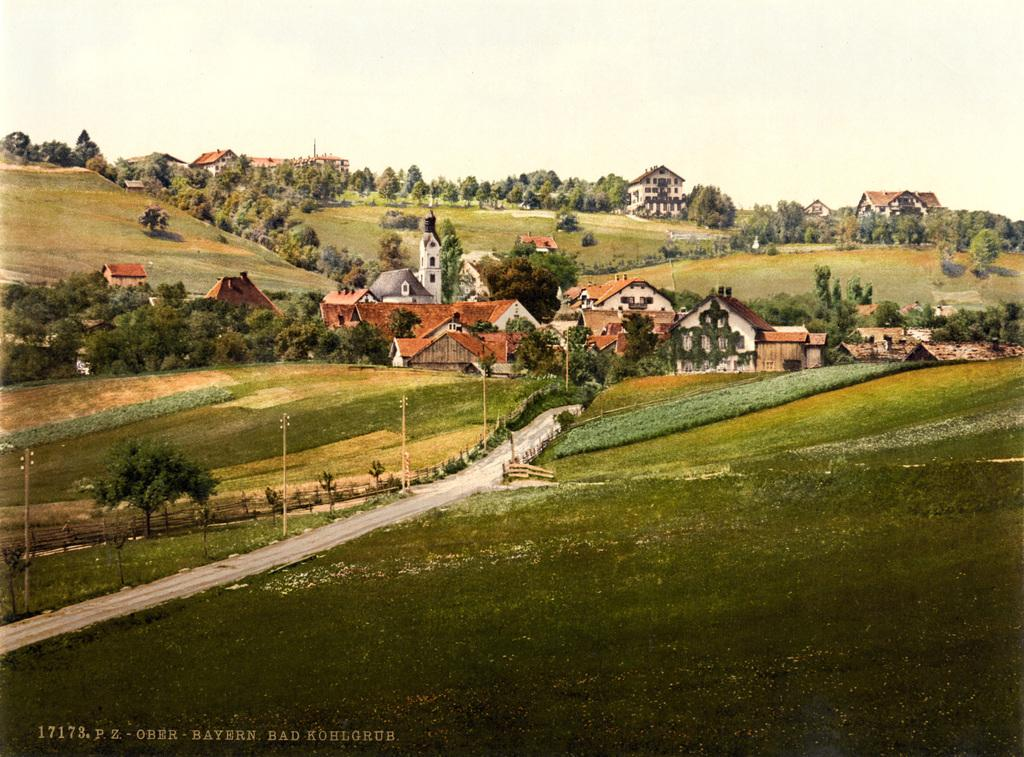What type of vegetation can be seen in the image? There are trees in the image. What is the color of the trees? The trees are green. What structures are present in the image? There are electric poles in the image. What can be seen in the background of the image? There are houses in the background of the image. What is the color of the sky in the image? The sky is white in color. What type of quartz can be seen in the image? There is no quartz present in the image. Are there any ghosts visible in the image? There are no ghosts present in the image. 